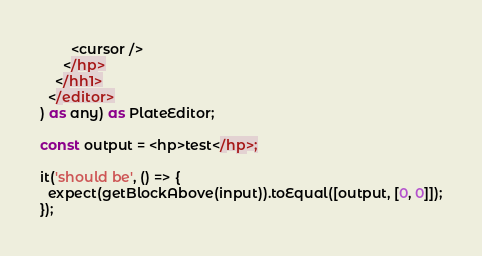<code> <loc_0><loc_0><loc_500><loc_500><_TypeScript_>        <cursor />
      </hp>
    </hh1>
  </editor>
) as any) as PlateEditor;

const output = <hp>test</hp>;

it('should be', () => {
  expect(getBlockAbove(input)).toEqual([output, [0, 0]]);
});
</code> 